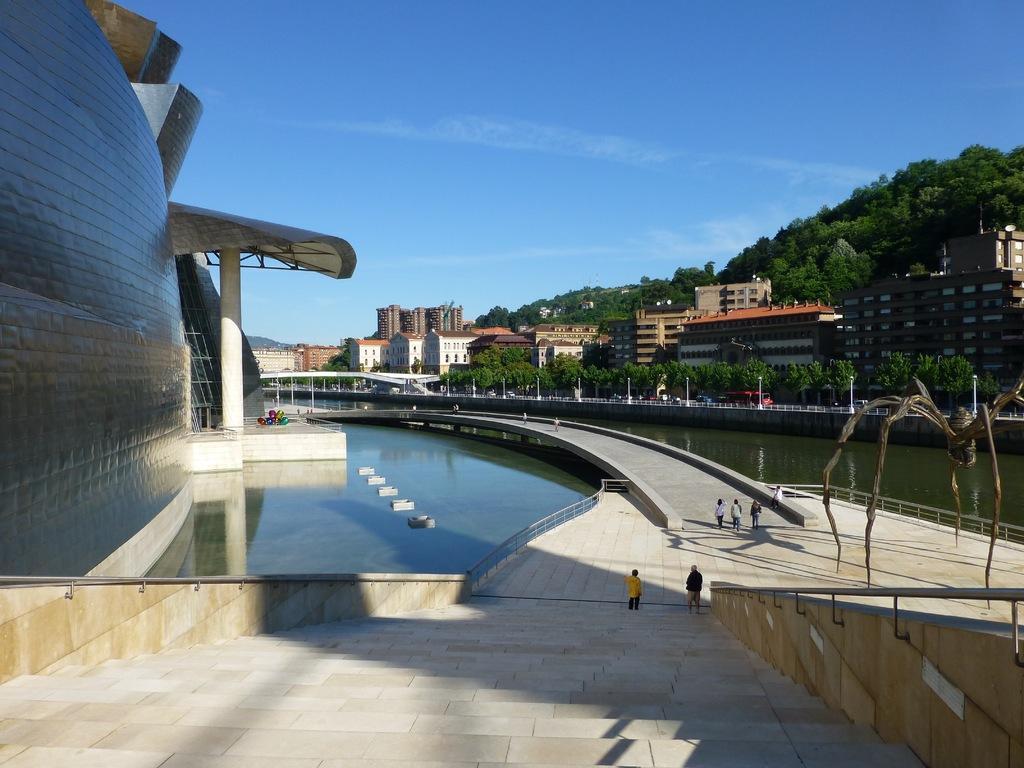Could you give a brief overview of what you see in this image? In this image we can see the buildings, trees, light poles, railing, bridgewater, stairs and also the people. We can also see the sky. 